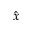Convert formula to latex. <formula><loc_0><loc_0><loc_500><loc_500>\hat { x }</formula> 